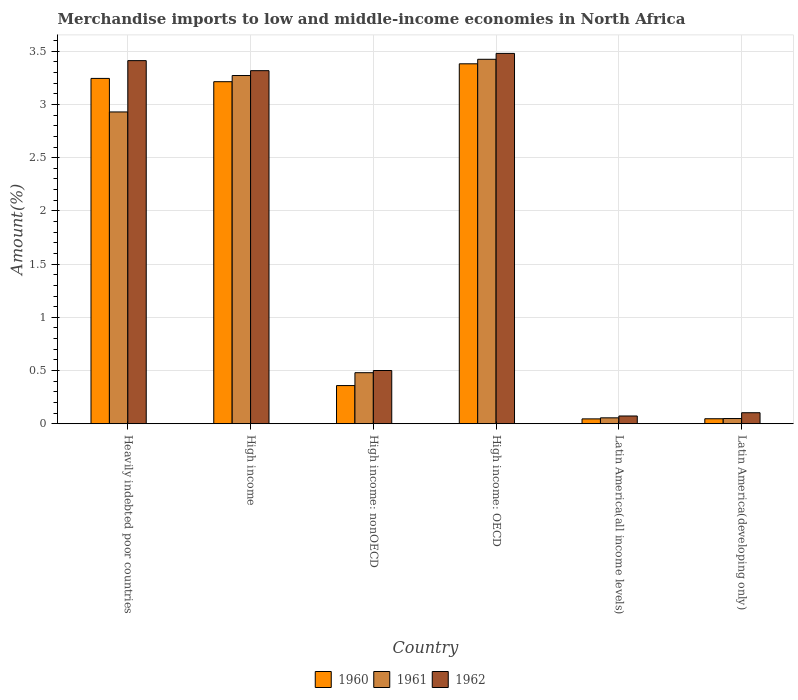How many different coloured bars are there?
Provide a short and direct response. 3. Are the number of bars on each tick of the X-axis equal?
Provide a short and direct response. Yes. What is the label of the 6th group of bars from the left?
Your answer should be compact. Latin America(developing only). In how many cases, is the number of bars for a given country not equal to the number of legend labels?
Offer a very short reply. 0. What is the percentage of amount earned from merchandise imports in 1960 in Latin America(developing only)?
Your response must be concise. 0.05. Across all countries, what is the maximum percentage of amount earned from merchandise imports in 1961?
Offer a terse response. 3.42. Across all countries, what is the minimum percentage of amount earned from merchandise imports in 1961?
Offer a very short reply. 0.05. In which country was the percentage of amount earned from merchandise imports in 1960 maximum?
Make the answer very short. High income: OECD. In which country was the percentage of amount earned from merchandise imports in 1960 minimum?
Provide a short and direct response. Latin America(all income levels). What is the total percentage of amount earned from merchandise imports in 1961 in the graph?
Provide a succinct answer. 10.21. What is the difference between the percentage of amount earned from merchandise imports in 1960 in Heavily indebted poor countries and that in Latin America(developing only)?
Give a very brief answer. 3.2. What is the difference between the percentage of amount earned from merchandise imports in 1961 in High income: OECD and the percentage of amount earned from merchandise imports in 1960 in High income: nonOECD?
Your answer should be compact. 3.07. What is the average percentage of amount earned from merchandise imports in 1961 per country?
Provide a short and direct response. 1.7. What is the difference between the percentage of amount earned from merchandise imports of/in 1960 and percentage of amount earned from merchandise imports of/in 1961 in High income: nonOECD?
Ensure brevity in your answer.  -0.12. In how many countries, is the percentage of amount earned from merchandise imports in 1960 greater than 0.8 %?
Your response must be concise. 3. What is the ratio of the percentage of amount earned from merchandise imports in 1961 in High income to that in High income: nonOECD?
Offer a very short reply. 6.82. What is the difference between the highest and the second highest percentage of amount earned from merchandise imports in 1961?
Ensure brevity in your answer.  0.34. What is the difference between the highest and the lowest percentage of amount earned from merchandise imports in 1961?
Your answer should be very brief. 3.38. What does the 3rd bar from the right in High income represents?
Offer a very short reply. 1960. How many bars are there?
Keep it short and to the point. 18. What is the difference between two consecutive major ticks on the Y-axis?
Give a very brief answer. 0.5. Does the graph contain grids?
Ensure brevity in your answer.  Yes. How are the legend labels stacked?
Offer a terse response. Horizontal. What is the title of the graph?
Your response must be concise. Merchandise imports to low and middle-income economies in North Africa. What is the label or title of the Y-axis?
Offer a very short reply. Amount(%). What is the Amount(%) in 1960 in Heavily indebted poor countries?
Offer a very short reply. 3.24. What is the Amount(%) of 1961 in Heavily indebted poor countries?
Offer a very short reply. 2.93. What is the Amount(%) of 1962 in Heavily indebted poor countries?
Ensure brevity in your answer.  3.41. What is the Amount(%) of 1960 in High income?
Your response must be concise. 3.21. What is the Amount(%) in 1961 in High income?
Your answer should be very brief. 3.27. What is the Amount(%) in 1962 in High income?
Give a very brief answer. 3.32. What is the Amount(%) in 1960 in High income: nonOECD?
Provide a short and direct response. 0.36. What is the Amount(%) of 1961 in High income: nonOECD?
Offer a very short reply. 0.48. What is the Amount(%) of 1962 in High income: nonOECD?
Ensure brevity in your answer.  0.5. What is the Amount(%) in 1960 in High income: OECD?
Your answer should be compact. 3.38. What is the Amount(%) in 1961 in High income: OECD?
Make the answer very short. 3.42. What is the Amount(%) of 1962 in High income: OECD?
Give a very brief answer. 3.48. What is the Amount(%) in 1960 in Latin America(all income levels)?
Offer a very short reply. 0.05. What is the Amount(%) in 1961 in Latin America(all income levels)?
Ensure brevity in your answer.  0.06. What is the Amount(%) of 1962 in Latin America(all income levels)?
Give a very brief answer. 0.07. What is the Amount(%) in 1960 in Latin America(developing only)?
Offer a very short reply. 0.05. What is the Amount(%) of 1961 in Latin America(developing only)?
Offer a terse response. 0.05. What is the Amount(%) of 1962 in Latin America(developing only)?
Make the answer very short. 0.1. Across all countries, what is the maximum Amount(%) in 1960?
Your response must be concise. 3.38. Across all countries, what is the maximum Amount(%) of 1961?
Your answer should be very brief. 3.42. Across all countries, what is the maximum Amount(%) of 1962?
Provide a short and direct response. 3.48. Across all countries, what is the minimum Amount(%) in 1960?
Offer a terse response. 0.05. Across all countries, what is the minimum Amount(%) in 1961?
Provide a short and direct response. 0.05. Across all countries, what is the minimum Amount(%) of 1962?
Your response must be concise. 0.07. What is the total Amount(%) of 1960 in the graph?
Your response must be concise. 10.29. What is the total Amount(%) in 1961 in the graph?
Give a very brief answer. 10.21. What is the total Amount(%) of 1962 in the graph?
Give a very brief answer. 10.89. What is the difference between the Amount(%) of 1960 in Heavily indebted poor countries and that in High income?
Offer a very short reply. 0.03. What is the difference between the Amount(%) of 1961 in Heavily indebted poor countries and that in High income?
Provide a short and direct response. -0.34. What is the difference between the Amount(%) of 1962 in Heavily indebted poor countries and that in High income?
Your answer should be compact. 0.09. What is the difference between the Amount(%) of 1960 in Heavily indebted poor countries and that in High income: nonOECD?
Your answer should be compact. 2.89. What is the difference between the Amount(%) in 1961 in Heavily indebted poor countries and that in High income: nonOECD?
Your answer should be very brief. 2.45. What is the difference between the Amount(%) of 1962 in Heavily indebted poor countries and that in High income: nonOECD?
Make the answer very short. 2.91. What is the difference between the Amount(%) in 1960 in Heavily indebted poor countries and that in High income: OECD?
Your answer should be compact. -0.14. What is the difference between the Amount(%) of 1961 in Heavily indebted poor countries and that in High income: OECD?
Offer a terse response. -0.49. What is the difference between the Amount(%) of 1962 in Heavily indebted poor countries and that in High income: OECD?
Your response must be concise. -0.07. What is the difference between the Amount(%) of 1960 in Heavily indebted poor countries and that in Latin America(all income levels)?
Give a very brief answer. 3.2. What is the difference between the Amount(%) in 1961 in Heavily indebted poor countries and that in Latin America(all income levels)?
Your answer should be compact. 2.87. What is the difference between the Amount(%) of 1962 in Heavily indebted poor countries and that in Latin America(all income levels)?
Make the answer very short. 3.34. What is the difference between the Amount(%) of 1960 in Heavily indebted poor countries and that in Latin America(developing only)?
Your answer should be very brief. 3.2. What is the difference between the Amount(%) of 1961 in Heavily indebted poor countries and that in Latin America(developing only)?
Provide a short and direct response. 2.88. What is the difference between the Amount(%) in 1962 in Heavily indebted poor countries and that in Latin America(developing only)?
Ensure brevity in your answer.  3.31. What is the difference between the Amount(%) of 1960 in High income and that in High income: nonOECD?
Your answer should be very brief. 2.86. What is the difference between the Amount(%) in 1961 in High income and that in High income: nonOECD?
Ensure brevity in your answer.  2.79. What is the difference between the Amount(%) in 1962 in High income and that in High income: nonOECD?
Give a very brief answer. 2.82. What is the difference between the Amount(%) of 1960 in High income and that in High income: OECD?
Your answer should be compact. -0.17. What is the difference between the Amount(%) in 1961 in High income and that in High income: OECD?
Give a very brief answer. -0.15. What is the difference between the Amount(%) of 1962 in High income and that in High income: OECD?
Your answer should be compact. -0.16. What is the difference between the Amount(%) of 1960 in High income and that in Latin America(all income levels)?
Keep it short and to the point. 3.17. What is the difference between the Amount(%) of 1961 in High income and that in Latin America(all income levels)?
Your response must be concise. 3.22. What is the difference between the Amount(%) of 1962 in High income and that in Latin America(all income levels)?
Make the answer very short. 3.24. What is the difference between the Amount(%) in 1960 in High income and that in Latin America(developing only)?
Your answer should be compact. 3.17. What is the difference between the Amount(%) in 1961 in High income and that in Latin America(developing only)?
Make the answer very short. 3.22. What is the difference between the Amount(%) of 1962 in High income and that in Latin America(developing only)?
Provide a short and direct response. 3.21. What is the difference between the Amount(%) of 1960 in High income: nonOECD and that in High income: OECD?
Your response must be concise. -3.02. What is the difference between the Amount(%) in 1961 in High income: nonOECD and that in High income: OECD?
Keep it short and to the point. -2.94. What is the difference between the Amount(%) in 1962 in High income: nonOECD and that in High income: OECD?
Make the answer very short. -2.98. What is the difference between the Amount(%) of 1960 in High income: nonOECD and that in Latin America(all income levels)?
Make the answer very short. 0.31. What is the difference between the Amount(%) of 1961 in High income: nonOECD and that in Latin America(all income levels)?
Keep it short and to the point. 0.42. What is the difference between the Amount(%) of 1962 in High income: nonOECD and that in Latin America(all income levels)?
Make the answer very short. 0.43. What is the difference between the Amount(%) in 1960 in High income: nonOECD and that in Latin America(developing only)?
Provide a short and direct response. 0.31. What is the difference between the Amount(%) in 1961 in High income: nonOECD and that in Latin America(developing only)?
Your response must be concise. 0.43. What is the difference between the Amount(%) of 1962 in High income: nonOECD and that in Latin America(developing only)?
Your answer should be very brief. 0.4. What is the difference between the Amount(%) in 1960 in High income: OECD and that in Latin America(all income levels)?
Offer a very short reply. 3.34. What is the difference between the Amount(%) of 1961 in High income: OECD and that in Latin America(all income levels)?
Provide a short and direct response. 3.37. What is the difference between the Amount(%) in 1962 in High income: OECD and that in Latin America(all income levels)?
Your answer should be compact. 3.41. What is the difference between the Amount(%) in 1960 in High income: OECD and that in Latin America(developing only)?
Offer a very short reply. 3.33. What is the difference between the Amount(%) in 1961 in High income: OECD and that in Latin America(developing only)?
Your answer should be compact. 3.38. What is the difference between the Amount(%) in 1962 in High income: OECD and that in Latin America(developing only)?
Provide a short and direct response. 3.38. What is the difference between the Amount(%) of 1960 in Latin America(all income levels) and that in Latin America(developing only)?
Provide a succinct answer. -0. What is the difference between the Amount(%) of 1961 in Latin America(all income levels) and that in Latin America(developing only)?
Provide a short and direct response. 0.01. What is the difference between the Amount(%) of 1962 in Latin America(all income levels) and that in Latin America(developing only)?
Give a very brief answer. -0.03. What is the difference between the Amount(%) of 1960 in Heavily indebted poor countries and the Amount(%) of 1961 in High income?
Ensure brevity in your answer.  -0.03. What is the difference between the Amount(%) of 1960 in Heavily indebted poor countries and the Amount(%) of 1962 in High income?
Offer a very short reply. -0.07. What is the difference between the Amount(%) of 1961 in Heavily indebted poor countries and the Amount(%) of 1962 in High income?
Your response must be concise. -0.39. What is the difference between the Amount(%) in 1960 in Heavily indebted poor countries and the Amount(%) in 1961 in High income: nonOECD?
Your answer should be compact. 2.77. What is the difference between the Amount(%) of 1960 in Heavily indebted poor countries and the Amount(%) of 1962 in High income: nonOECD?
Make the answer very short. 2.74. What is the difference between the Amount(%) in 1961 in Heavily indebted poor countries and the Amount(%) in 1962 in High income: nonOECD?
Offer a very short reply. 2.43. What is the difference between the Amount(%) in 1960 in Heavily indebted poor countries and the Amount(%) in 1961 in High income: OECD?
Provide a short and direct response. -0.18. What is the difference between the Amount(%) of 1960 in Heavily indebted poor countries and the Amount(%) of 1962 in High income: OECD?
Ensure brevity in your answer.  -0.23. What is the difference between the Amount(%) in 1961 in Heavily indebted poor countries and the Amount(%) in 1962 in High income: OECD?
Offer a terse response. -0.55. What is the difference between the Amount(%) in 1960 in Heavily indebted poor countries and the Amount(%) in 1961 in Latin America(all income levels)?
Your response must be concise. 3.19. What is the difference between the Amount(%) of 1960 in Heavily indebted poor countries and the Amount(%) of 1962 in Latin America(all income levels)?
Your response must be concise. 3.17. What is the difference between the Amount(%) in 1961 in Heavily indebted poor countries and the Amount(%) in 1962 in Latin America(all income levels)?
Keep it short and to the point. 2.86. What is the difference between the Amount(%) in 1960 in Heavily indebted poor countries and the Amount(%) in 1961 in Latin America(developing only)?
Provide a succinct answer. 3.2. What is the difference between the Amount(%) in 1960 in Heavily indebted poor countries and the Amount(%) in 1962 in Latin America(developing only)?
Offer a very short reply. 3.14. What is the difference between the Amount(%) of 1961 in Heavily indebted poor countries and the Amount(%) of 1962 in Latin America(developing only)?
Offer a terse response. 2.83. What is the difference between the Amount(%) of 1960 in High income and the Amount(%) of 1961 in High income: nonOECD?
Your answer should be compact. 2.73. What is the difference between the Amount(%) in 1960 in High income and the Amount(%) in 1962 in High income: nonOECD?
Give a very brief answer. 2.71. What is the difference between the Amount(%) of 1961 in High income and the Amount(%) of 1962 in High income: nonOECD?
Your response must be concise. 2.77. What is the difference between the Amount(%) in 1960 in High income and the Amount(%) in 1961 in High income: OECD?
Offer a terse response. -0.21. What is the difference between the Amount(%) in 1960 in High income and the Amount(%) in 1962 in High income: OECD?
Make the answer very short. -0.27. What is the difference between the Amount(%) of 1961 in High income and the Amount(%) of 1962 in High income: OECD?
Your answer should be compact. -0.21. What is the difference between the Amount(%) in 1960 in High income and the Amount(%) in 1961 in Latin America(all income levels)?
Provide a short and direct response. 3.16. What is the difference between the Amount(%) in 1960 in High income and the Amount(%) in 1962 in Latin America(all income levels)?
Provide a short and direct response. 3.14. What is the difference between the Amount(%) in 1961 in High income and the Amount(%) in 1962 in Latin America(all income levels)?
Give a very brief answer. 3.2. What is the difference between the Amount(%) of 1960 in High income and the Amount(%) of 1961 in Latin America(developing only)?
Provide a succinct answer. 3.17. What is the difference between the Amount(%) of 1960 in High income and the Amount(%) of 1962 in Latin America(developing only)?
Give a very brief answer. 3.11. What is the difference between the Amount(%) in 1961 in High income and the Amount(%) in 1962 in Latin America(developing only)?
Offer a very short reply. 3.17. What is the difference between the Amount(%) of 1960 in High income: nonOECD and the Amount(%) of 1961 in High income: OECD?
Your answer should be compact. -3.07. What is the difference between the Amount(%) of 1960 in High income: nonOECD and the Amount(%) of 1962 in High income: OECD?
Give a very brief answer. -3.12. What is the difference between the Amount(%) in 1961 in High income: nonOECD and the Amount(%) in 1962 in High income: OECD?
Give a very brief answer. -3. What is the difference between the Amount(%) in 1960 in High income: nonOECD and the Amount(%) in 1961 in Latin America(all income levels)?
Your answer should be very brief. 0.3. What is the difference between the Amount(%) in 1960 in High income: nonOECD and the Amount(%) in 1962 in Latin America(all income levels)?
Your response must be concise. 0.29. What is the difference between the Amount(%) of 1961 in High income: nonOECD and the Amount(%) of 1962 in Latin America(all income levels)?
Provide a short and direct response. 0.41. What is the difference between the Amount(%) in 1960 in High income: nonOECD and the Amount(%) in 1961 in Latin America(developing only)?
Ensure brevity in your answer.  0.31. What is the difference between the Amount(%) of 1960 in High income: nonOECD and the Amount(%) of 1962 in Latin America(developing only)?
Your answer should be very brief. 0.26. What is the difference between the Amount(%) in 1961 in High income: nonOECD and the Amount(%) in 1962 in Latin America(developing only)?
Ensure brevity in your answer.  0.38. What is the difference between the Amount(%) in 1960 in High income: OECD and the Amount(%) in 1961 in Latin America(all income levels)?
Your answer should be very brief. 3.33. What is the difference between the Amount(%) of 1960 in High income: OECD and the Amount(%) of 1962 in Latin America(all income levels)?
Give a very brief answer. 3.31. What is the difference between the Amount(%) in 1961 in High income: OECD and the Amount(%) in 1962 in Latin America(all income levels)?
Provide a succinct answer. 3.35. What is the difference between the Amount(%) in 1960 in High income: OECD and the Amount(%) in 1961 in Latin America(developing only)?
Make the answer very short. 3.33. What is the difference between the Amount(%) in 1960 in High income: OECD and the Amount(%) in 1962 in Latin America(developing only)?
Your response must be concise. 3.28. What is the difference between the Amount(%) of 1961 in High income: OECD and the Amount(%) of 1962 in Latin America(developing only)?
Give a very brief answer. 3.32. What is the difference between the Amount(%) in 1960 in Latin America(all income levels) and the Amount(%) in 1961 in Latin America(developing only)?
Your answer should be compact. -0. What is the difference between the Amount(%) in 1960 in Latin America(all income levels) and the Amount(%) in 1962 in Latin America(developing only)?
Your answer should be compact. -0.06. What is the difference between the Amount(%) in 1961 in Latin America(all income levels) and the Amount(%) in 1962 in Latin America(developing only)?
Keep it short and to the point. -0.05. What is the average Amount(%) of 1960 per country?
Offer a very short reply. 1.72. What is the average Amount(%) in 1961 per country?
Make the answer very short. 1.7. What is the average Amount(%) of 1962 per country?
Your answer should be very brief. 1.81. What is the difference between the Amount(%) in 1960 and Amount(%) in 1961 in Heavily indebted poor countries?
Provide a succinct answer. 0.32. What is the difference between the Amount(%) of 1960 and Amount(%) of 1962 in Heavily indebted poor countries?
Offer a very short reply. -0.17. What is the difference between the Amount(%) of 1961 and Amount(%) of 1962 in Heavily indebted poor countries?
Give a very brief answer. -0.48. What is the difference between the Amount(%) in 1960 and Amount(%) in 1961 in High income?
Provide a succinct answer. -0.06. What is the difference between the Amount(%) in 1960 and Amount(%) in 1962 in High income?
Your answer should be compact. -0.1. What is the difference between the Amount(%) of 1961 and Amount(%) of 1962 in High income?
Your response must be concise. -0.05. What is the difference between the Amount(%) of 1960 and Amount(%) of 1961 in High income: nonOECD?
Give a very brief answer. -0.12. What is the difference between the Amount(%) in 1960 and Amount(%) in 1962 in High income: nonOECD?
Provide a short and direct response. -0.14. What is the difference between the Amount(%) in 1961 and Amount(%) in 1962 in High income: nonOECD?
Make the answer very short. -0.02. What is the difference between the Amount(%) in 1960 and Amount(%) in 1961 in High income: OECD?
Your answer should be very brief. -0.04. What is the difference between the Amount(%) in 1960 and Amount(%) in 1962 in High income: OECD?
Ensure brevity in your answer.  -0.1. What is the difference between the Amount(%) of 1961 and Amount(%) of 1962 in High income: OECD?
Your answer should be very brief. -0.06. What is the difference between the Amount(%) of 1960 and Amount(%) of 1961 in Latin America(all income levels)?
Your response must be concise. -0.01. What is the difference between the Amount(%) in 1960 and Amount(%) in 1962 in Latin America(all income levels)?
Offer a terse response. -0.03. What is the difference between the Amount(%) in 1961 and Amount(%) in 1962 in Latin America(all income levels)?
Offer a very short reply. -0.02. What is the difference between the Amount(%) of 1960 and Amount(%) of 1961 in Latin America(developing only)?
Ensure brevity in your answer.  -0. What is the difference between the Amount(%) of 1960 and Amount(%) of 1962 in Latin America(developing only)?
Make the answer very short. -0.06. What is the difference between the Amount(%) in 1961 and Amount(%) in 1962 in Latin America(developing only)?
Make the answer very short. -0.05. What is the ratio of the Amount(%) in 1960 in Heavily indebted poor countries to that in High income?
Ensure brevity in your answer.  1.01. What is the ratio of the Amount(%) in 1961 in Heavily indebted poor countries to that in High income?
Your answer should be compact. 0.9. What is the ratio of the Amount(%) in 1962 in Heavily indebted poor countries to that in High income?
Offer a very short reply. 1.03. What is the ratio of the Amount(%) of 1960 in Heavily indebted poor countries to that in High income: nonOECD?
Your response must be concise. 9.05. What is the ratio of the Amount(%) in 1961 in Heavily indebted poor countries to that in High income: nonOECD?
Make the answer very short. 6.11. What is the ratio of the Amount(%) in 1962 in Heavily indebted poor countries to that in High income: nonOECD?
Ensure brevity in your answer.  6.82. What is the ratio of the Amount(%) of 1960 in Heavily indebted poor countries to that in High income: OECD?
Give a very brief answer. 0.96. What is the ratio of the Amount(%) of 1961 in Heavily indebted poor countries to that in High income: OECD?
Make the answer very short. 0.86. What is the ratio of the Amount(%) in 1962 in Heavily indebted poor countries to that in High income: OECD?
Ensure brevity in your answer.  0.98. What is the ratio of the Amount(%) in 1960 in Heavily indebted poor countries to that in Latin America(all income levels)?
Provide a succinct answer. 71.08. What is the ratio of the Amount(%) in 1961 in Heavily indebted poor countries to that in Latin America(all income levels)?
Ensure brevity in your answer.  52.86. What is the ratio of the Amount(%) of 1962 in Heavily indebted poor countries to that in Latin America(all income levels)?
Your answer should be compact. 46.85. What is the ratio of the Amount(%) in 1960 in Heavily indebted poor countries to that in Latin America(developing only)?
Provide a short and direct response. 69.16. What is the ratio of the Amount(%) in 1961 in Heavily indebted poor countries to that in Latin America(developing only)?
Give a very brief answer. 60. What is the ratio of the Amount(%) of 1962 in Heavily indebted poor countries to that in Latin America(developing only)?
Ensure brevity in your answer.  32.96. What is the ratio of the Amount(%) in 1960 in High income to that in High income: nonOECD?
Your answer should be very brief. 8.96. What is the ratio of the Amount(%) in 1961 in High income to that in High income: nonOECD?
Provide a short and direct response. 6.82. What is the ratio of the Amount(%) in 1962 in High income to that in High income: nonOECD?
Keep it short and to the point. 6.63. What is the ratio of the Amount(%) in 1960 in High income to that in High income: OECD?
Offer a very short reply. 0.95. What is the ratio of the Amount(%) in 1961 in High income to that in High income: OECD?
Your answer should be compact. 0.96. What is the ratio of the Amount(%) of 1962 in High income to that in High income: OECD?
Your response must be concise. 0.95. What is the ratio of the Amount(%) in 1960 in High income to that in Latin America(all income levels)?
Keep it short and to the point. 70.4. What is the ratio of the Amount(%) in 1961 in High income to that in Latin America(all income levels)?
Provide a short and direct response. 59.03. What is the ratio of the Amount(%) of 1962 in High income to that in Latin America(all income levels)?
Your answer should be very brief. 45.55. What is the ratio of the Amount(%) of 1960 in High income to that in Latin America(developing only)?
Your answer should be very brief. 68.5. What is the ratio of the Amount(%) in 1961 in High income to that in Latin America(developing only)?
Your answer should be compact. 67.01. What is the ratio of the Amount(%) of 1962 in High income to that in Latin America(developing only)?
Offer a very short reply. 32.05. What is the ratio of the Amount(%) of 1960 in High income: nonOECD to that in High income: OECD?
Offer a very short reply. 0.11. What is the ratio of the Amount(%) in 1961 in High income: nonOECD to that in High income: OECD?
Give a very brief answer. 0.14. What is the ratio of the Amount(%) in 1962 in High income: nonOECD to that in High income: OECD?
Give a very brief answer. 0.14. What is the ratio of the Amount(%) of 1960 in High income: nonOECD to that in Latin America(all income levels)?
Your answer should be very brief. 7.86. What is the ratio of the Amount(%) of 1961 in High income: nonOECD to that in Latin America(all income levels)?
Provide a short and direct response. 8.65. What is the ratio of the Amount(%) in 1962 in High income: nonOECD to that in Latin America(all income levels)?
Your answer should be very brief. 6.87. What is the ratio of the Amount(%) in 1960 in High income: nonOECD to that in Latin America(developing only)?
Provide a succinct answer. 7.64. What is the ratio of the Amount(%) of 1961 in High income: nonOECD to that in Latin America(developing only)?
Provide a short and direct response. 9.82. What is the ratio of the Amount(%) in 1962 in High income: nonOECD to that in Latin America(developing only)?
Give a very brief answer. 4.83. What is the ratio of the Amount(%) of 1960 in High income: OECD to that in Latin America(all income levels)?
Provide a short and direct response. 74.09. What is the ratio of the Amount(%) of 1961 in High income: OECD to that in Latin America(all income levels)?
Provide a short and direct response. 61.78. What is the ratio of the Amount(%) of 1962 in High income: OECD to that in Latin America(all income levels)?
Offer a very short reply. 47.78. What is the ratio of the Amount(%) in 1960 in High income: OECD to that in Latin America(developing only)?
Your answer should be very brief. 72.08. What is the ratio of the Amount(%) in 1961 in High income: OECD to that in Latin America(developing only)?
Provide a succinct answer. 70.14. What is the ratio of the Amount(%) of 1962 in High income: OECD to that in Latin America(developing only)?
Provide a short and direct response. 33.62. What is the ratio of the Amount(%) of 1960 in Latin America(all income levels) to that in Latin America(developing only)?
Offer a terse response. 0.97. What is the ratio of the Amount(%) in 1961 in Latin America(all income levels) to that in Latin America(developing only)?
Provide a short and direct response. 1.14. What is the ratio of the Amount(%) in 1962 in Latin America(all income levels) to that in Latin America(developing only)?
Your response must be concise. 0.7. What is the difference between the highest and the second highest Amount(%) in 1960?
Give a very brief answer. 0.14. What is the difference between the highest and the second highest Amount(%) of 1961?
Provide a succinct answer. 0.15. What is the difference between the highest and the second highest Amount(%) of 1962?
Make the answer very short. 0.07. What is the difference between the highest and the lowest Amount(%) of 1960?
Offer a very short reply. 3.34. What is the difference between the highest and the lowest Amount(%) of 1961?
Offer a very short reply. 3.38. What is the difference between the highest and the lowest Amount(%) of 1962?
Make the answer very short. 3.41. 